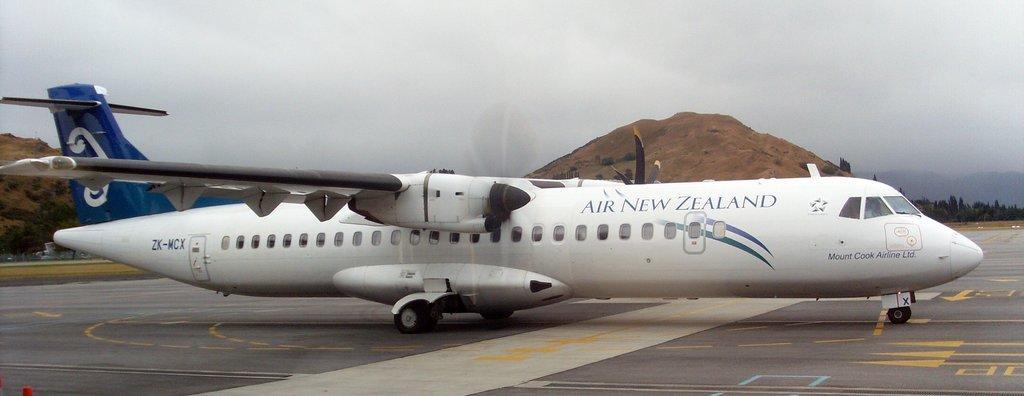Describe this image in one or two sentences. This picture shows an aeroplane and we see rocks and few trees and a cloudy Sky. It is white and blue in color. 